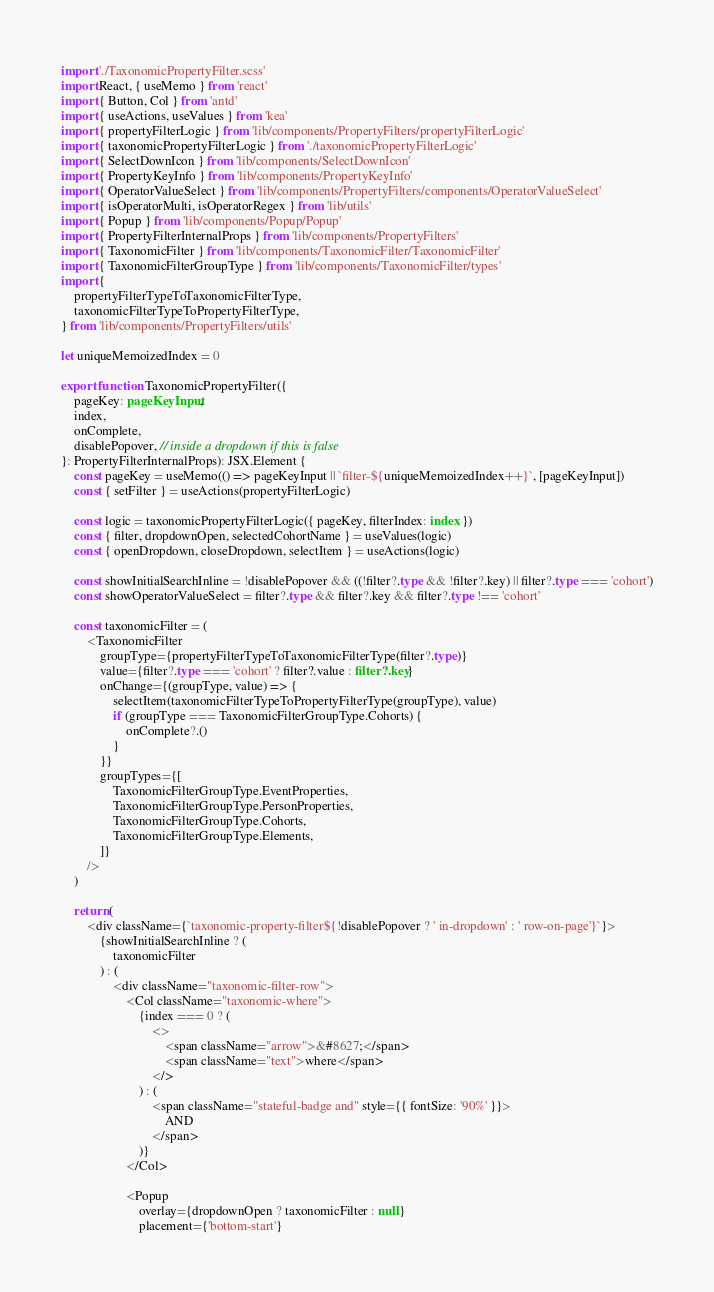<code> <loc_0><loc_0><loc_500><loc_500><_TypeScript_>import './TaxonomicPropertyFilter.scss'
import React, { useMemo } from 'react'
import { Button, Col } from 'antd'
import { useActions, useValues } from 'kea'
import { propertyFilterLogic } from 'lib/components/PropertyFilters/propertyFilterLogic'
import { taxonomicPropertyFilterLogic } from './taxonomicPropertyFilterLogic'
import { SelectDownIcon } from 'lib/components/SelectDownIcon'
import { PropertyKeyInfo } from 'lib/components/PropertyKeyInfo'
import { OperatorValueSelect } from 'lib/components/PropertyFilters/components/OperatorValueSelect'
import { isOperatorMulti, isOperatorRegex } from 'lib/utils'
import { Popup } from 'lib/components/Popup/Popup'
import { PropertyFilterInternalProps } from 'lib/components/PropertyFilters'
import { TaxonomicFilter } from 'lib/components/TaxonomicFilter/TaxonomicFilter'
import { TaxonomicFilterGroupType } from 'lib/components/TaxonomicFilter/types'
import {
    propertyFilterTypeToTaxonomicFilterType,
    taxonomicFilterTypeToPropertyFilterType,
} from 'lib/components/PropertyFilters/utils'

let uniqueMemoizedIndex = 0

export function TaxonomicPropertyFilter({
    pageKey: pageKeyInput,
    index,
    onComplete,
    disablePopover, // inside a dropdown if this is false
}: PropertyFilterInternalProps): JSX.Element {
    const pageKey = useMemo(() => pageKeyInput || `filter-${uniqueMemoizedIndex++}`, [pageKeyInput])
    const { setFilter } = useActions(propertyFilterLogic)

    const logic = taxonomicPropertyFilterLogic({ pageKey, filterIndex: index })
    const { filter, dropdownOpen, selectedCohortName } = useValues(logic)
    const { openDropdown, closeDropdown, selectItem } = useActions(logic)

    const showInitialSearchInline = !disablePopover && ((!filter?.type && !filter?.key) || filter?.type === 'cohort')
    const showOperatorValueSelect = filter?.type && filter?.key && filter?.type !== 'cohort'

    const taxonomicFilter = (
        <TaxonomicFilter
            groupType={propertyFilterTypeToTaxonomicFilterType(filter?.type)}
            value={filter?.type === 'cohort' ? filter?.value : filter?.key}
            onChange={(groupType, value) => {
                selectItem(taxonomicFilterTypeToPropertyFilterType(groupType), value)
                if (groupType === TaxonomicFilterGroupType.Cohorts) {
                    onComplete?.()
                }
            }}
            groupTypes={[
                TaxonomicFilterGroupType.EventProperties,
                TaxonomicFilterGroupType.PersonProperties,
                TaxonomicFilterGroupType.Cohorts,
                TaxonomicFilterGroupType.Elements,
            ]}
        />
    )

    return (
        <div className={`taxonomic-property-filter${!disablePopover ? ' in-dropdown' : ' row-on-page'}`}>
            {showInitialSearchInline ? (
                taxonomicFilter
            ) : (
                <div className="taxonomic-filter-row">
                    <Col className="taxonomic-where">
                        {index === 0 ? (
                            <>
                                <span className="arrow">&#8627;</span>
                                <span className="text">where</span>
                            </>
                        ) : (
                            <span className="stateful-badge and" style={{ fontSize: '90%' }}>
                                AND
                            </span>
                        )}
                    </Col>

                    <Popup
                        overlay={dropdownOpen ? taxonomicFilter : null}
                        placement={'bottom-start'}</code> 